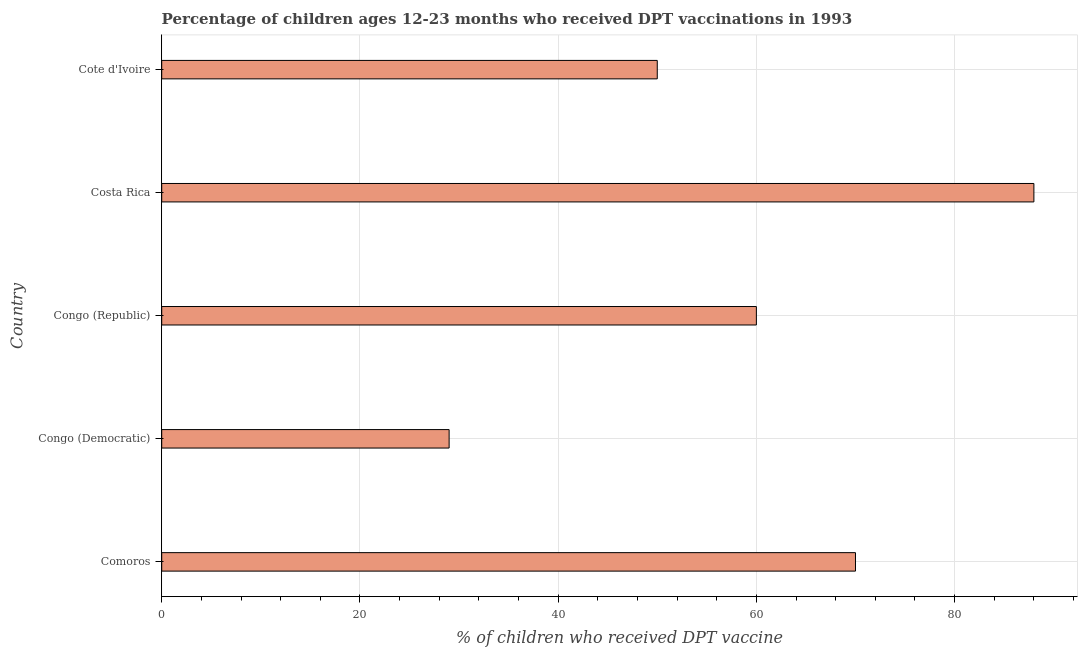Does the graph contain grids?
Provide a short and direct response. Yes. What is the title of the graph?
Your response must be concise. Percentage of children ages 12-23 months who received DPT vaccinations in 1993. What is the label or title of the X-axis?
Provide a short and direct response. % of children who received DPT vaccine. What is the percentage of children who received dpt vaccine in Costa Rica?
Offer a terse response. 88. In which country was the percentage of children who received dpt vaccine minimum?
Your answer should be very brief. Congo (Democratic). What is the sum of the percentage of children who received dpt vaccine?
Offer a very short reply. 297. What is the average percentage of children who received dpt vaccine per country?
Make the answer very short. 59.4. In how many countries, is the percentage of children who received dpt vaccine greater than 12 %?
Your answer should be very brief. 5. What is the ratio of the percentage of children who received dpt vaccine in Congo (Democratic) to that in Cote d'Ivoire?
Give a very brief answer. 0.58. Is the percentage of children who received dpt vaccine in Congo (Democratic) less than that in Costa Rica?
Give a very brief answer. Yes. What is the difference between the highest and the second highest percentage of children who received dpt vaccine?
Provide a short and direct response. 18. Is the sum of the percentage of children who received dpt vaccine in Comoros and Costa Rica greater than the maximum percentage of children who received dpt vaccine across all countries?
Keep it short and to the point. Yes. What is the difference between the highest and the lowest percentage of children who received dpt vaccine?
Keep it short and to the point. 59. In how many countries, is the percentage of children who received dpt vaccine greater than the average percentage of children who received dpt vaccine taken over all countries?
Give a very brief answer. 3. How many bars are there?
Offer a terse response. 5. How many countries are there in the graph?
Your answer should be compact. 5. What is the difference between two consecutive major ticks on the X-axis?
Keep it short and to the point. 20. Are the values on the major ticks of X-axis written in scientific E-notation?
Make the answer very short. No. What is the % of children who received DPT vaccine in Comoros?
Provide a succinct answer. 70. What is the % of children who received DPT vaccine of Congo (Democratic)?
Your response must be concise. 29. What is the % of children who received DPT vaccine in Costa Rica?
Give a very brief answer. 88. What is the difference between the % of children who received DPT vaccine in Comoros and Congo (Democratic)?
Offer a terse response. 41. What is the difference between the % of children who received DPT vaccine in Comoros and Cote d'Ivoire?
Offer a terse response. 20. What is the difference between the % of children who received DPT vaccine in Congo (Democratic) and Congo (Republic)?
Your response must be concise. -31. What is the difference between the % of children who received DPT vaccine in Congo (Democratic) and Costa Rica?
Give a very brief answer. -59. What is the difference between the % of children who received DPT vaccine in Congo (Democratic) and Cote d'Ivoire?
Make the answer very short. -21. What is the difference between the % of children who received DPT vaccine in Congo (Republic) and Costa Rica?
Make the answer very short. -28. What is the ratio of the % of children who received DPT vaccine in Comoros to that in Congo (Democratic)?
Your response must be concise. 2.41. What is the ratio of the % of children who received DPT vaccine in Comoros to that in Congo (Republic)?
Ensure brevity in your answer.  1.17. What is the ratio of the % of children who received DPT vaccine in Comoros to that in Costa Rica?
Your response must be concise. 0.8. What is the ratio of the % of children who received DPT vaccine in Comoros to that in Cote d'Ivoire?
Give a very brief answer. 1.4. What is the ratio of the % of children who received DPT vaccine in Congo (Democratic) to that in Congo (Republic)?
Give a very brief answer. 0.48. What is the ratio of the % of children who received DPT vaccine in Congo (Democratic) to that in Costa Rica?
Your response must be concise. 0.33. What is the ratio of the % of children who received DPT vaccine in Congo (Democratic) to that in Cote d'Ivoire?
Your answer should be compact. 0.58. What is the ratio of the % of children who received DPT vaccine in Congo (Republic) to that in Costa Rica?
Make the answer very short. 0.68. What is the ratio of the % of children who received DPT vaccine in Costa Rica to that in Cote d'Ivoire?
Your response must be concise. 1.76. 